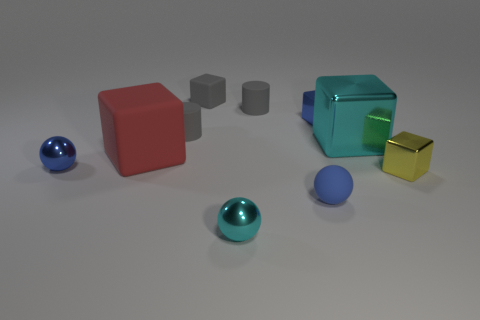There is another block that is the same size as the cyan cube; what is its material?
Provide a succinct answer. Rubber. Are there any other cubes made of the same material as the tiny yellow block?
Provide a short and direct response. Yes. Does the big cyan shiny thing have the same shape as the blue metallic object that is to the right of the small cyan sphere?
Provide a succinct answer. Yes. How many tiny objects are both behind the big red matte block and left of the tiny cyan ball?
Your answer should be compact. 2. Are the big red object and the yellow thing that is in front of the large matte thing made of the same material?
Give a very brief answer. No. Are there the same number of small cyan metal things behind the big cyan cube and large green rubber cubes?
Provide a succinct answer. Yes. What color is the ball that is behind the blue matte sphere?
Your answer should be compact. Blue. What number of other objects are there of the same color as the tiny matte block?
Your response must be concise. 2. Does the metallic object that is in front of the yellow metallic block have the same size as the big red rubber cube?
Ensure brevity in your answer.  No. What is the blue thing on the left side of the cyan metal sphere made of?
Give a very brief answer. Metal. 